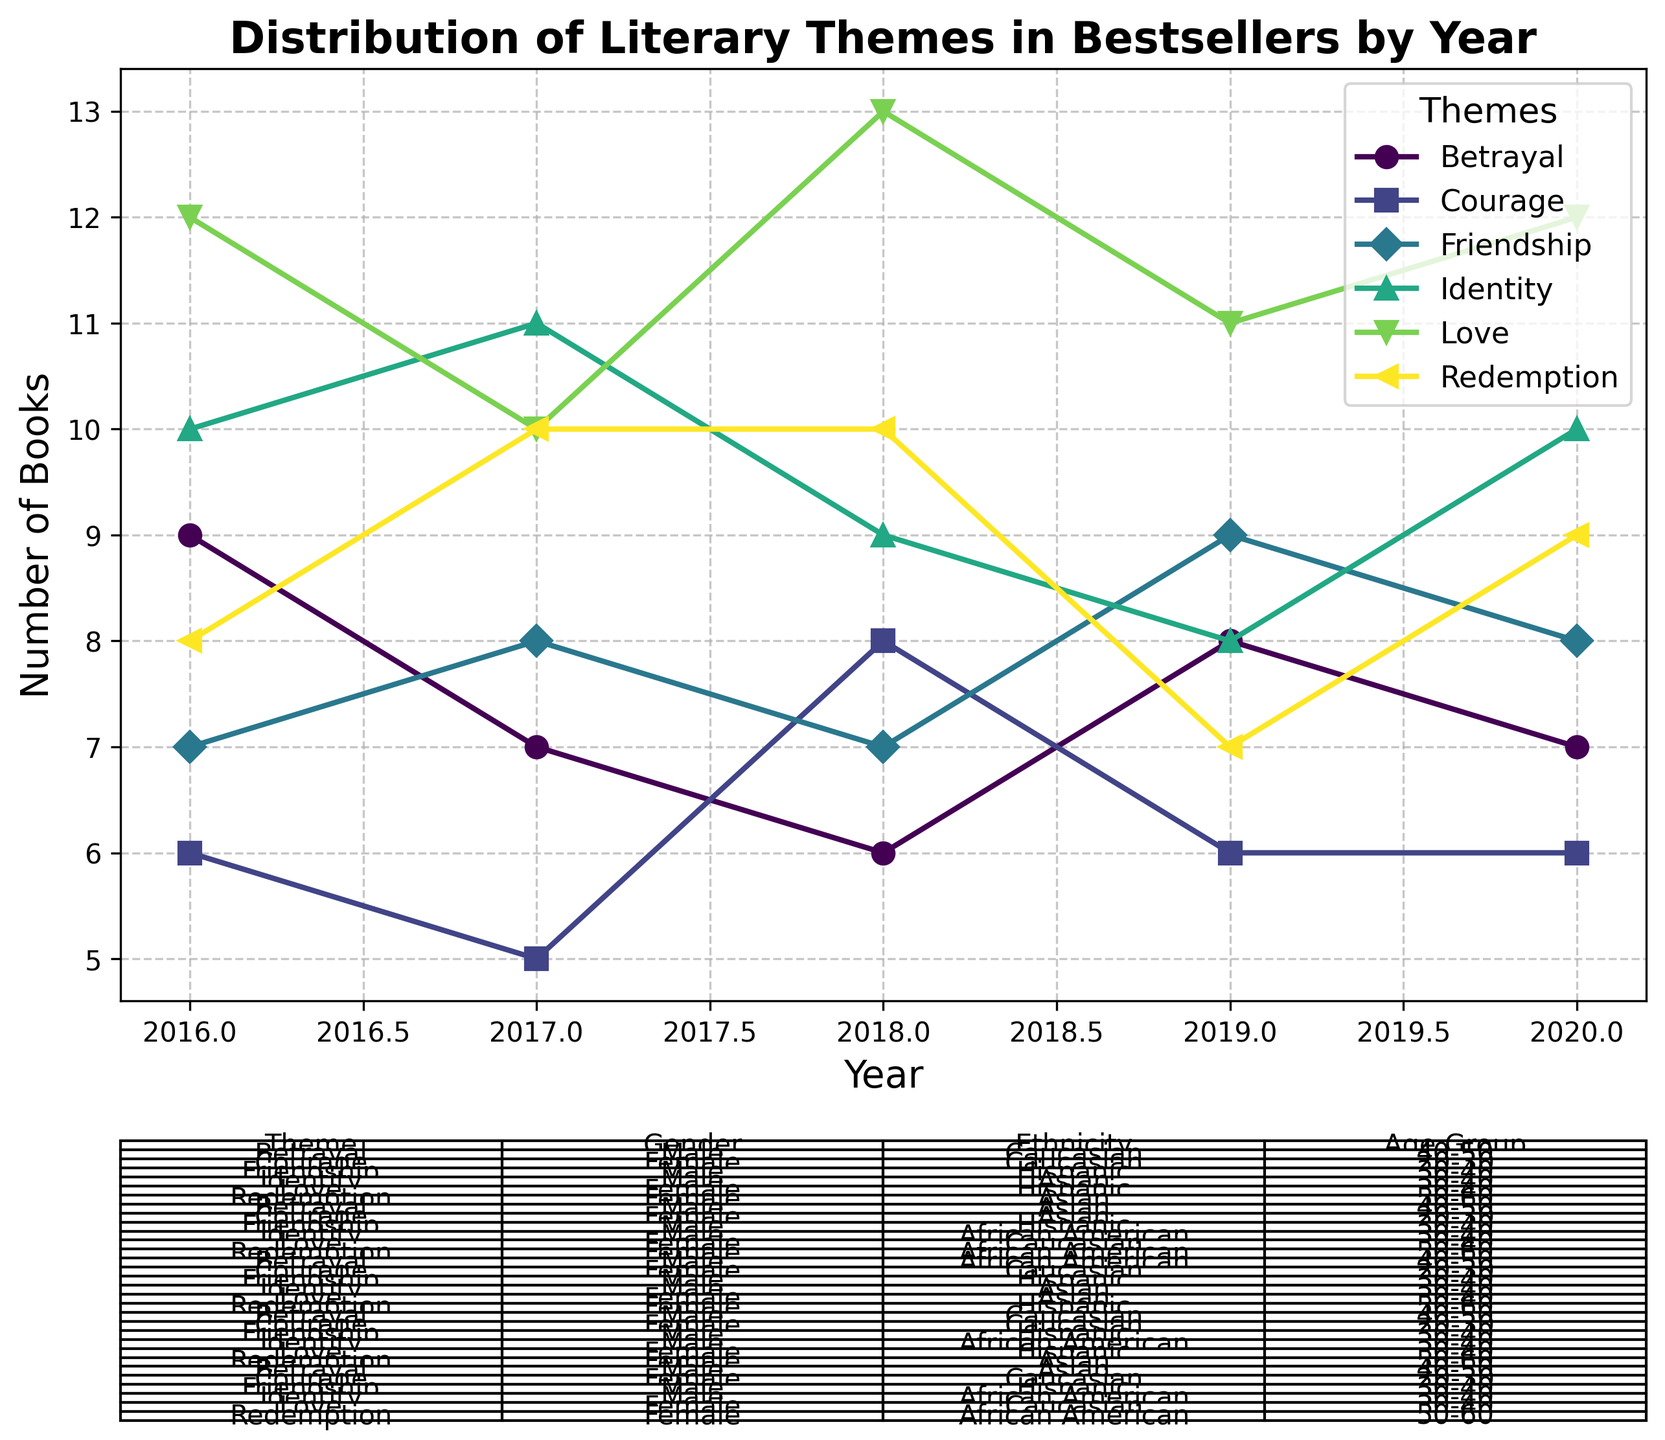Which year had the highest number of bestselling books with the theme "Love"? By checking the plot's lines and markers, we note that the peak value for the theme "Love" occurs in a specific year. This year is noted to have the highest marker on the line associated with the "Love" theme. Specifically, the year 2018 had 13 books with this theme, the highest number in the dataset.
Answer: 2018 Comparing 2019 and 2020, which theme had a greater increase in the number of books? Identify and compare the values for each theme between the two years. Note the differences between 2020 and 2019 for each theme. The theme "Identity" saw an increase from 8 books in 2019 to 10 books in 2020, while others had different changes, ultimately showing that "Identity" had a 2-book increase.
Answer: Identity What is the average number of bestselling books with the theme "Betrayal" across the years shown? Sum the number of "Betrayal" books for each year (7+8+6+7+9) and divide by the number of years (5). This gives (37/5) which is 7.4 books on average.
Answer: 7.4 In 2016, which theme was authored by the youngest age group? Refer to the table below the plot and identify the age groups for each theme in 2016. "Courage" was authored by individuals in the 20-30 age group, the youngest mentioned.
Answer: Courage Which theme shows a consistent or nearly consistent number of books each year from 2016 to 2020? Checking the plot lines, find which theme's line appears flat or nearly flat across the years. "Friendship" shows values of 7, 8, 7, 9, and 8 across the years, indicating its relatively consistent nature.
Answer: Friendship How many books with the theme "Redemption" were authored by African American adults in 2020? Refer to the table where themes are cross-referenced with demographic information. In 2020, "Redemption" has 9 books authored by African American adults within the 50-60 age group.
Answer: 9 Which ethnicity authored the most bestselling books with the theme "Identity" in 2017? Check the table for 2017's identity-themed books and note the ethnicity listed next to this theme. The table specifies these books were authored by African American writers.
Answer: African American Among the listed themes, which has the most variation in the number of books from year to year? Look for themes with the largest fluctuations in their line graph values. The theme "Love" fluctuates between 10 to 13 books indicating significant variation.
Answer: Love 